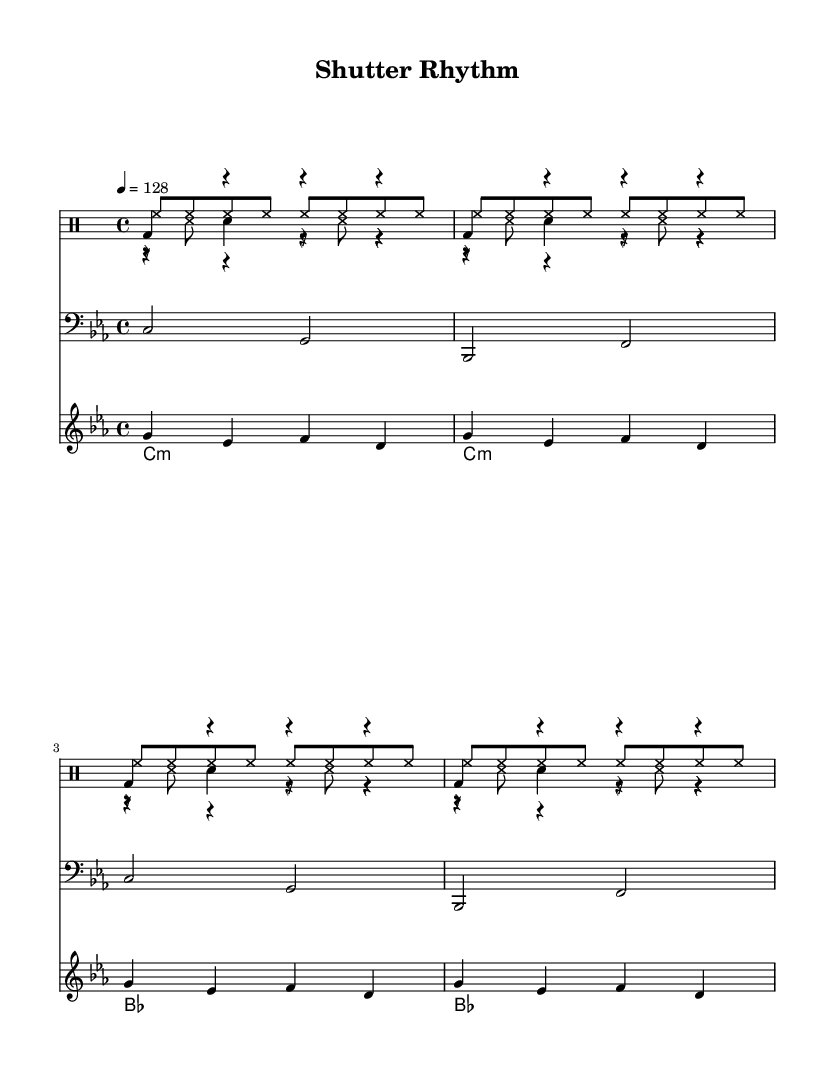What is the key signature of this music? The key signature is C minor, which has three flats (B♭, E♭, A♭). This can be identified from the key indication at the beginning of the score.
Answer: C minor What is the time signature of this music? The time signature is 4/4, meaning there are four beats per measure. This is indicated in the score right next to the key signature.
Answer: 4/4 What is the tempo marking in this piece? The tempo marking is indicated as "4 = 128," which means there are 128 quarter-note beats per minute. This is typically found and observed in the header of the score.
Answer: 128 What type of drum pattern is used for the main beat? The main beat features a kick drum pattern, which consists of the bass drum played on the first beat with rests following. This is shown through the notational representation of the kick pattern in the drum staff.
Answer: Kick drum How many bars are there in the synth bass section? The synth bass section is repeated twice, with each repetition consisting of 2 bars, resulting in a total of 4 bars visible on the score. This can be counted directly from the notation of the synth bass in the staff.
Answer: 4 bars What is the rhythmic pattern mimicking a camera shutter sound? The rhythmic pattern mimicking a camera shutter sound is indicated by the "shutterSound" part, which consists of rests and notes that create a staccato effect. This can be seen in the notation of that specific drum voice.
Answer: Shutter sound 